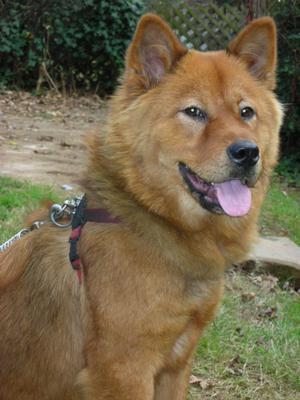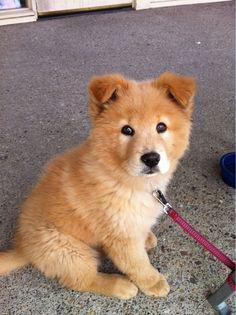The first image is the image on the left, the second image is the image on the right. Assess this claim about the two images: "The dog in the image on the left is standing.". Correct or not? Answer yes or no. No. The first image is the image on the left, the second image is the image on the right. For the images shown, is this caption "Right image features one dog, which is reclining with front paws forward." true? Answer yes or no. No. 